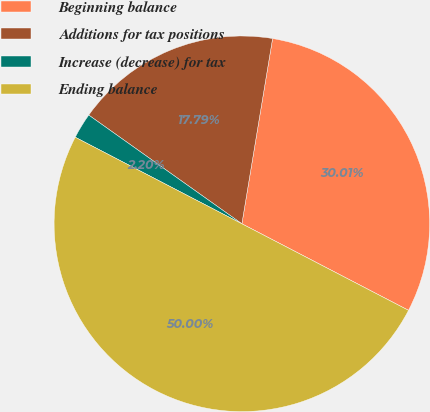Convert chart to OTSL. <chart><loc_0><loc_0><loc_500><loc_500><pie_chart><fcel>Beginning balance<fcel>Additions for tax positions<fcel>Increase (decrease) for tax<fcel>Ending balance<nl><fcel>30.01%<fcel>17.79%<fcel>2.2%<fcel>50.0%<nl></chart> 